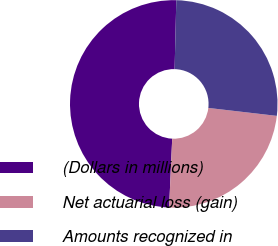Convert chart to OTSL. <chart><loc_0><loc_0><loc_500><loc_500><pie_chart><fcel>(Dollars in millions)<fcel>Net actuarial loss (gain)<fcel>Amounts recognized in<nl><fcel>49.67%<fcel>23.87%<fcel>26.45%<nl></chart> 